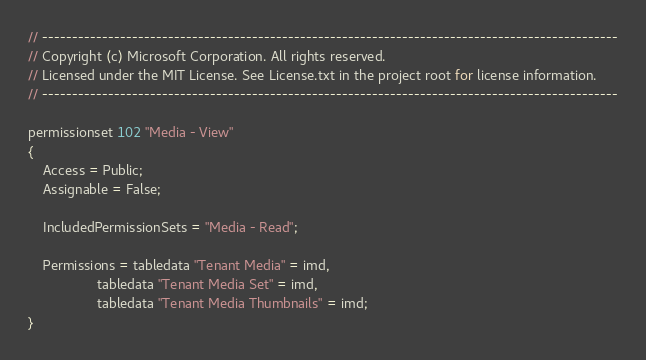<code> <loc_0><loc_0><loc_500><loc_500><_Perl_>// ------------------------------------------------------------------------------------------------
// Copyright (c) Microsoft Corporation. All rights reserved.
// Licensed under the MIT License. See License.txt in the project root for license information.
// ------------------------------------------------------------------------------------------------

permissionset 102 "Media - View"
{
    Access = Public;
    Assignable = False;

    IncludedPermissionSets = "Media - Read";

    Permissions = tabledata "Tenant Media" = imd,
                  tabledata "Tenant Media Set" = imd,
                  tabledata "Tenant Media Thumbnails" = imd;
}
</code> 